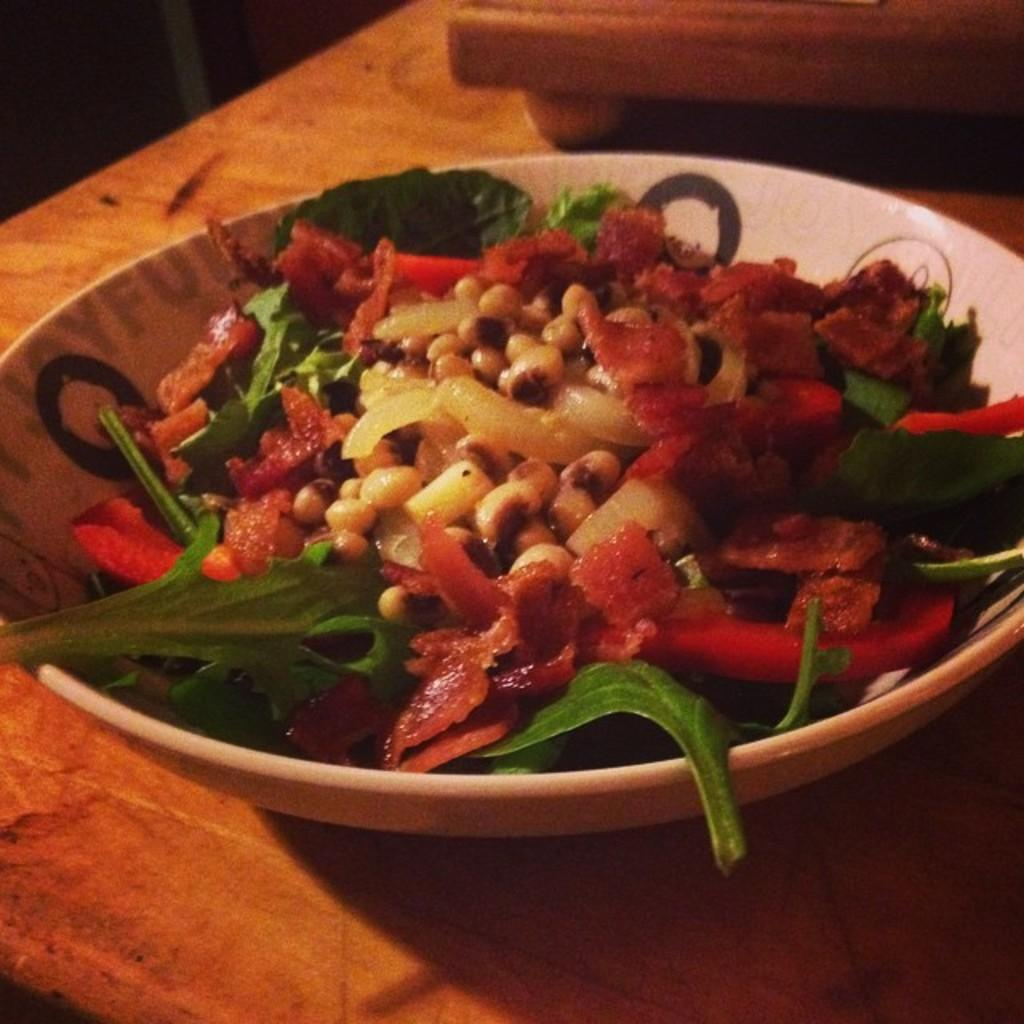What type of table is in the image? There is a wooden table in the image. What is on the table? There is a bowl with a food item on the table. What is added to the bowl for decoration? There is vegetable garnish on the bowl. What reward does the partner receive for completing the task in the image? There is no partner or task present in the image, so it is not possible to determine any reward. 